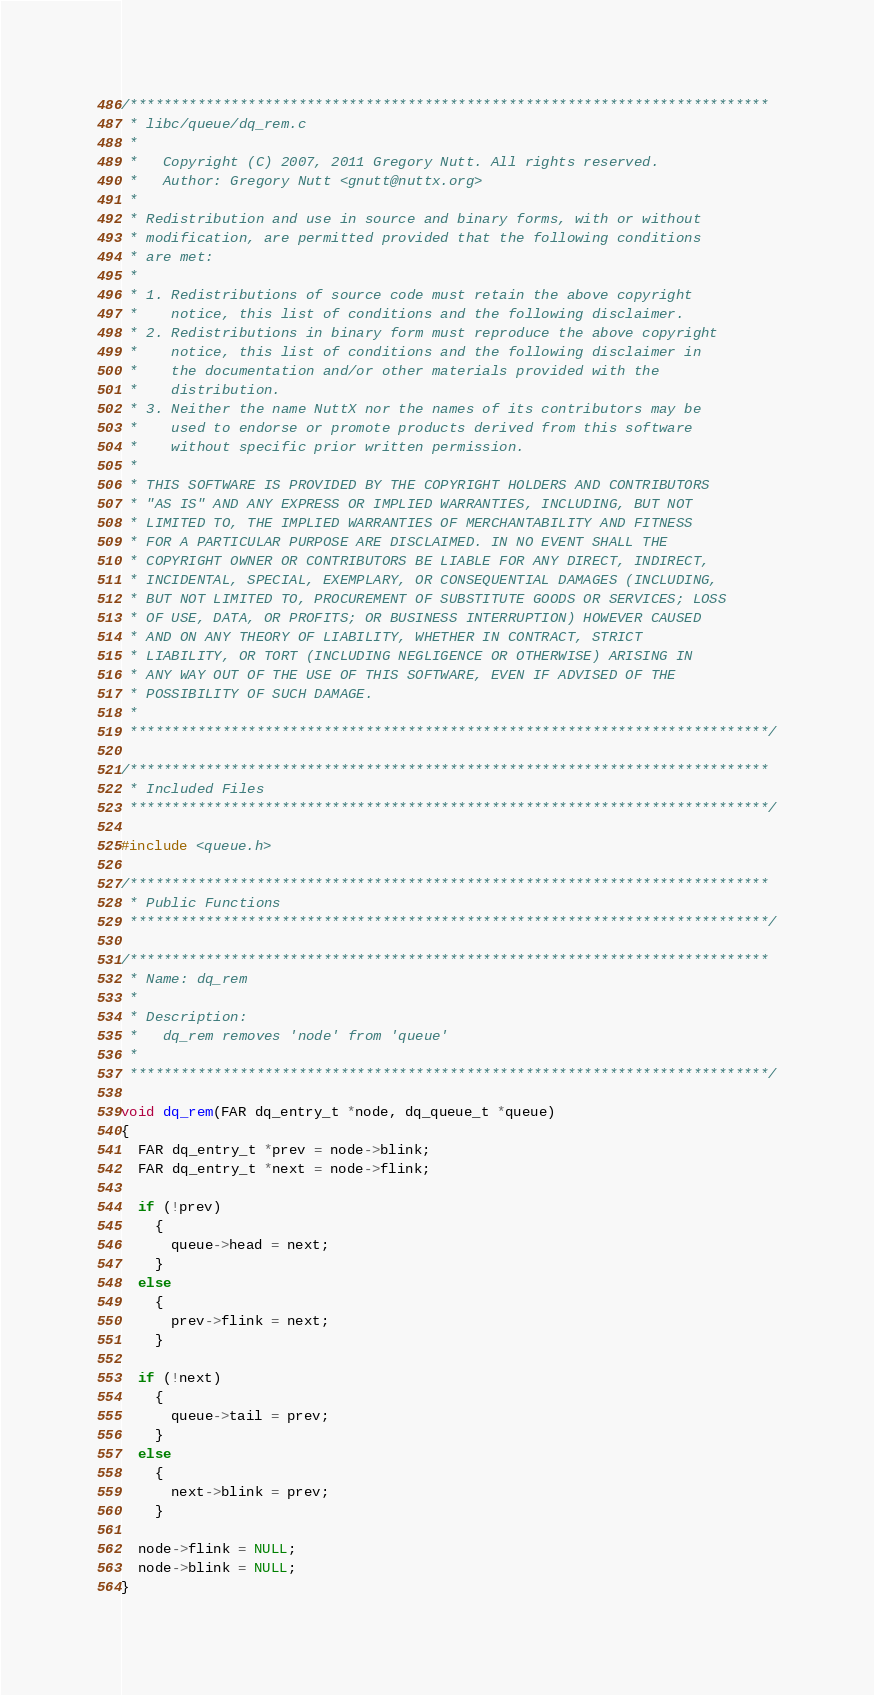Convert code to text. <code><loc_0><loc_0><loc_500><loc_500><_C_>/****************************************************************************
 * libc/queue/dq_rem.c
 *
 *   Copyright (C) 2007, 2011 Gregory Nutt. All rights reserved.
 *   Author: Gregory Nutt <gnutt@nuttx.org>
 *
 * Redistribution and use in source and binary forms, with or without
 * modification, are permitted provided that the following conditions
 * are met:
 *
 * 1. Redistributions of source code must retain the above copyright
 *    notice, this list of conditions and the following disclaimer.
 * 2. Redistributions in binary form must reproduce the above copyright
 *    notice, this list of conditions and the following disclaimer in
 *    the documentation and/or other materials provided with the
 *    distribution.
 * 3. Neither the name NuttX nor the names of its contributors may be
 *    used to endorse or promote products derived from this software
 *    without specific prior written permission.
 *
 * THIS SOFTWARE IS PROVIDED BY THE COPYRIGHT HOLDERS AND CONTRIBUTORS
 * "AS IS" AND ANY EXPRESS OR IMPLIED WARRANTIES, INCLUDING, BUT NOT
 * LIMITED TO, THE IMPLIED WARRANTIES OF MERCHANTABILITY AND FITNESS
 * FOR A PARTICULAR PURPOSE ARE DISCLAIMED. IN NO EVENT SHALL THE
 * COPYRIGHT OWNER OR CONTRIBUTORS BE LIABLE FOR ANY DIRECT, INDIRECT,
 * INCIDENTAL, SPECIAL, EXEMPLARY, OR CONSEQUENTIAL DAMAGES (INCLUDING,
 * BUT NOT LIMITED TO, PROCUREMENT OF SUBSTITUTE GOODS OR SERVICES; LOSS
 * OF USE, DATA, OR PROFITS; OR BUSINESS INTERRUPTION) HOWEVER CAUSED
 * AND ON ANY THEORY OF LIABILITY, WHETHER IN CONTRACT, STRICT
 * LIABILITY, OR TORT (INCLUDING NEGLIGENCE OR OTHERWISE) ARISING IN
 * ANY WAY OUT OF THE USE OF THIS SOFTWARE, EVEN IF ADVISED OF THE
 * POSSIBILITY OF SUCH DAMAGE.
 *
 ****************************************************************************/

/****************************************************************************
 * Included Files
 ****************************************************************************/

#include <queue.h>

/****************************************************************************
 * Public Functions
 ****************************************************************************/

/****************************************************************************
 * Name: dq_rem
 *
 * Description:
 *   dq_rem removes 'node' from 'queue'
 *
 ****************************************************************************/

void dq_rem(FAR dq_entry_t *node, dq_queue_t *queue)
{
  FAR dq_entry_t *prev = node->blink;
  FAR dq_entry_t *next = node->flink;

  if (!prev)
    {
      queue->head = next;
    }
  else
    {
      prev->flink = next;
    }

  if (!next)
    {
      queue->tail = prev;
    }
  else
    {
      next->blink = prev;
    }

  node->flink = NULL;
  node->blink = NULL;
}
</code> 